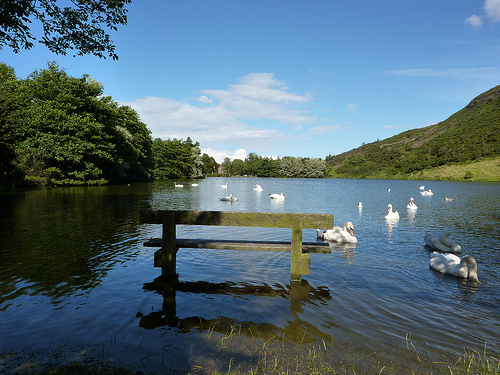<image>
Is there a swan behind the fence? Yes. From this viewpoint, the swan is positioned behind the fence, with the fence partially or fully occluding the swan. Is the goose in the water? Yes. The goose is contained within or inside the water, showing a containment relationship. Is the wood in front of the water? No. The wood is not in front of the water. The spatial positioning shows a different relationship between these objects. 